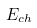Convert formula to latex. <formula><loc_0><loc_0><loc_500><loc_500>E _ { c h }</formula> 